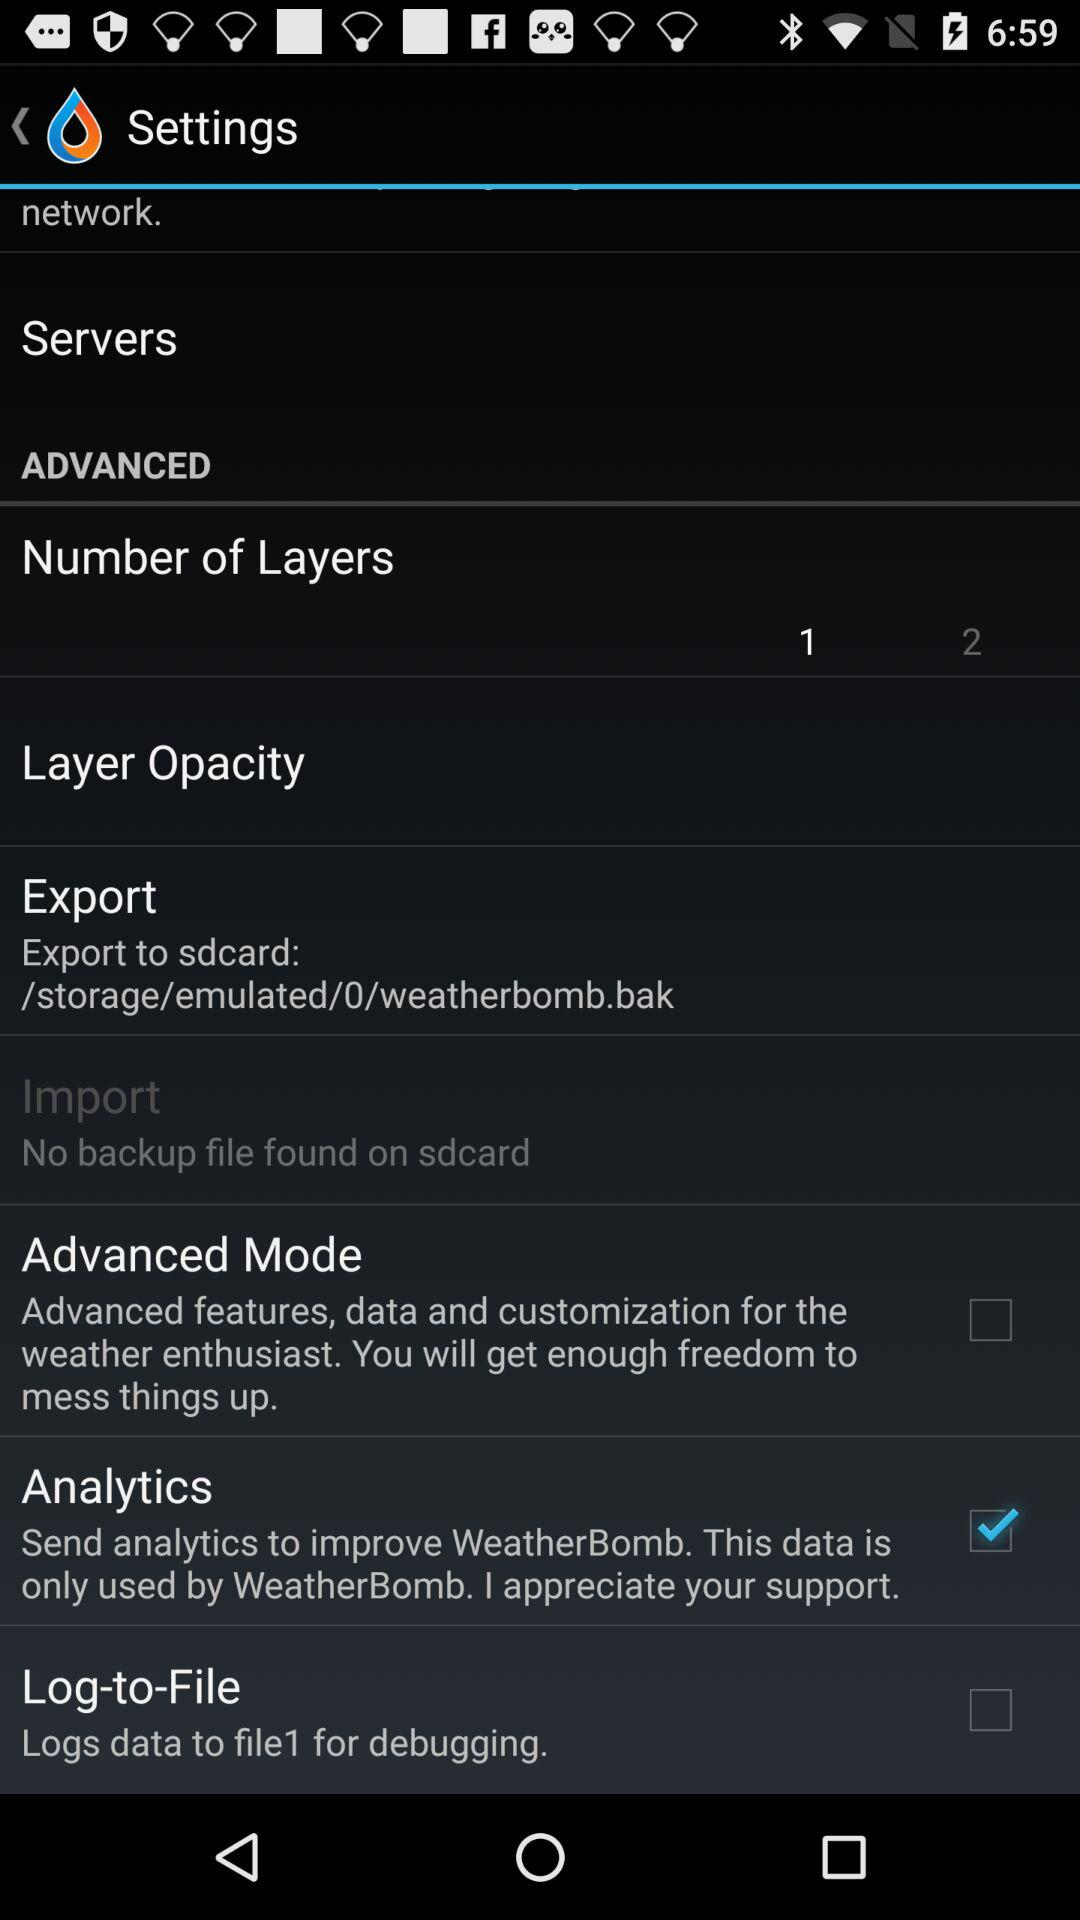How many layers were selected? There was 1 layer selected. 